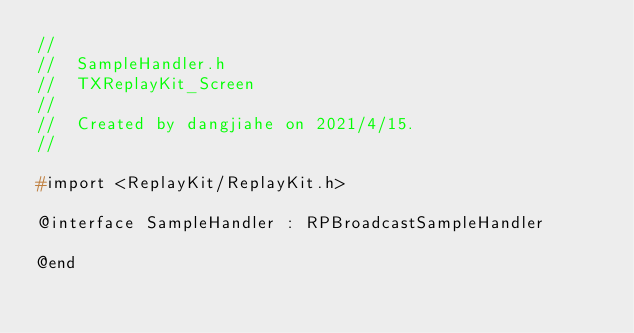Convert code to text. <code><loc_0><loc_0><loc_500><loc_500><_C_>//
//  SampleHandler.h
//  TXReplayKit_Screen
//
//  Created by dangjiahe on 2021/4/15.
//

#import <ReplayKit/ReplayKit.h>

@interface SampleHandler : RPBroadcastSampleHandler

@end
</code> 